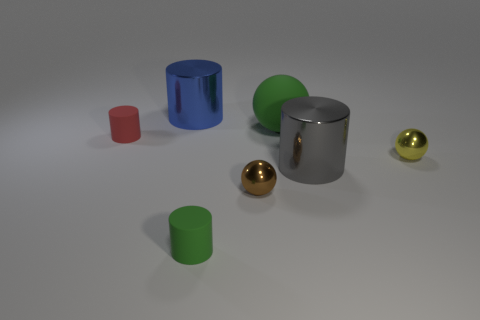Subtract 1 cylinders. How many cylinders are left? 3 Add 3 big yellow metal cylinders. How many objects exist? 10 Subtract all spheres. How many objects are left? 4 Add 3 green things. How many green things exist? 5 Subtract 0 brown cylinders. How many objects are left? 7 Subtract all tiny yellow metal spheres. Subtract all yellow things. How many objects are left? 5 Add 6 green rubber spheres. How many green rubber spheres are left? 7 